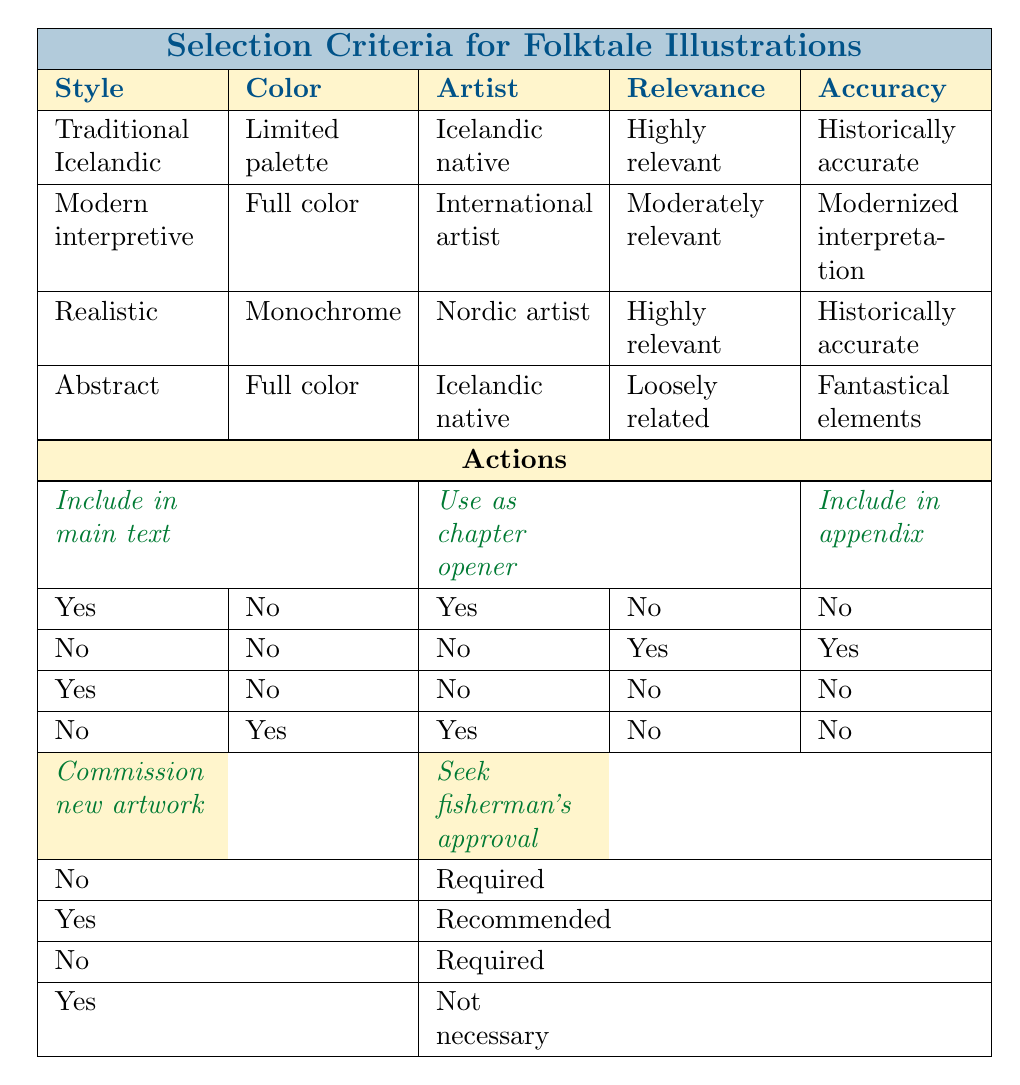What should be the artist’s background if the illustration style is "Traditional Icelandic"? According to the table, for the "Traditional Icelandic" illustration style, the artist's background should be "Icelandic native".
Answer: Icelandic native If the color scheme is "Full color," can the illustration be included in the main text? The table indicates that in the case of a "Full color" scheme, if the styles are "Modern interpretive" or "Abstract," the inclusion in the main text is a "No."
Answer: No What is the subject matter relevance when the illustration is created by an "International artist"? The table shows that if the artist is "International," the subject matter relevance is categorized as "Moderately relevant" under the "Modern interpretive" style.
Answer: Moderately relevant How many illustrations are included in the appendix among the four styles presented? By reviewing the table, two styles indicate inclusion in the appendix: "Modern interpretive" (Yes) and "Abstract" (No). Therefore, there are two instances resulting in an addition of one.
Answer: 1 If the illustration style is "Realistic," is it necessary to seek the fisherman's approval? The table reflects that for "Realistic" with "Monochrome" color, seeking the fisherman's approval is "Required."
Answer: Required What are the two actions for the "Abstract" illustration style? In this illustration style, under full color with loosely related subject matter and fantastical elements, the actions titled are: "Use as chapter opener" (Yes) and "Commission new artwork" (Yes).
Answer: Use as chapter opener, Commission new artwork Which illustration styles require seeking the fisherman's approval? The table indicates that the styles "Traditional Icelandic" and "Realistic" both require seeking the fisherman's approval, as stated under "Required."
Answer: Traditional Icelandic, Realistic If the illustration is "Abstract" and uses a "Full color" scheme, can it be included in the main text? The table clearly states that for "Abstract" illustrations with a "Full color" scheme, the answer is "No" for inclusion in the main text.
Answer: No 